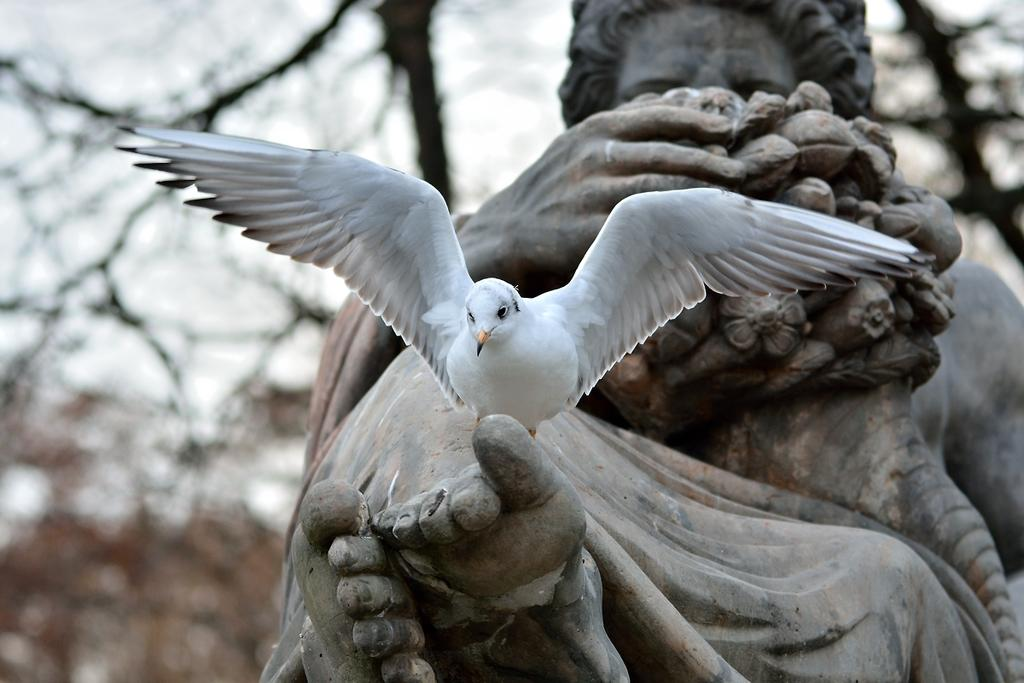What is on top of the statue in the image? There is a bird on a statue in the image. What can be seen in the background of the image? There is a tree and the sky visible in the background of the image. What type of produce is being harvested in the scene? There is no produce or harvesting activity depicted in the image; it features a bird on a statue with a tree and the sky in the background. 